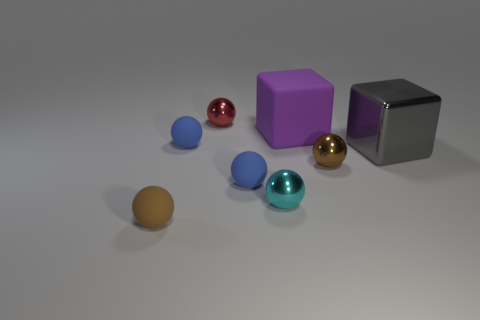There is a blue rubber sphere that is in front of the brown ball that is on the right side of the brown matte object; what is its size? The blue rubber sphere appears small in size, roughly in the range of 2 to 3 centimeters in diameter, considering the relative scale of objects in the image. 